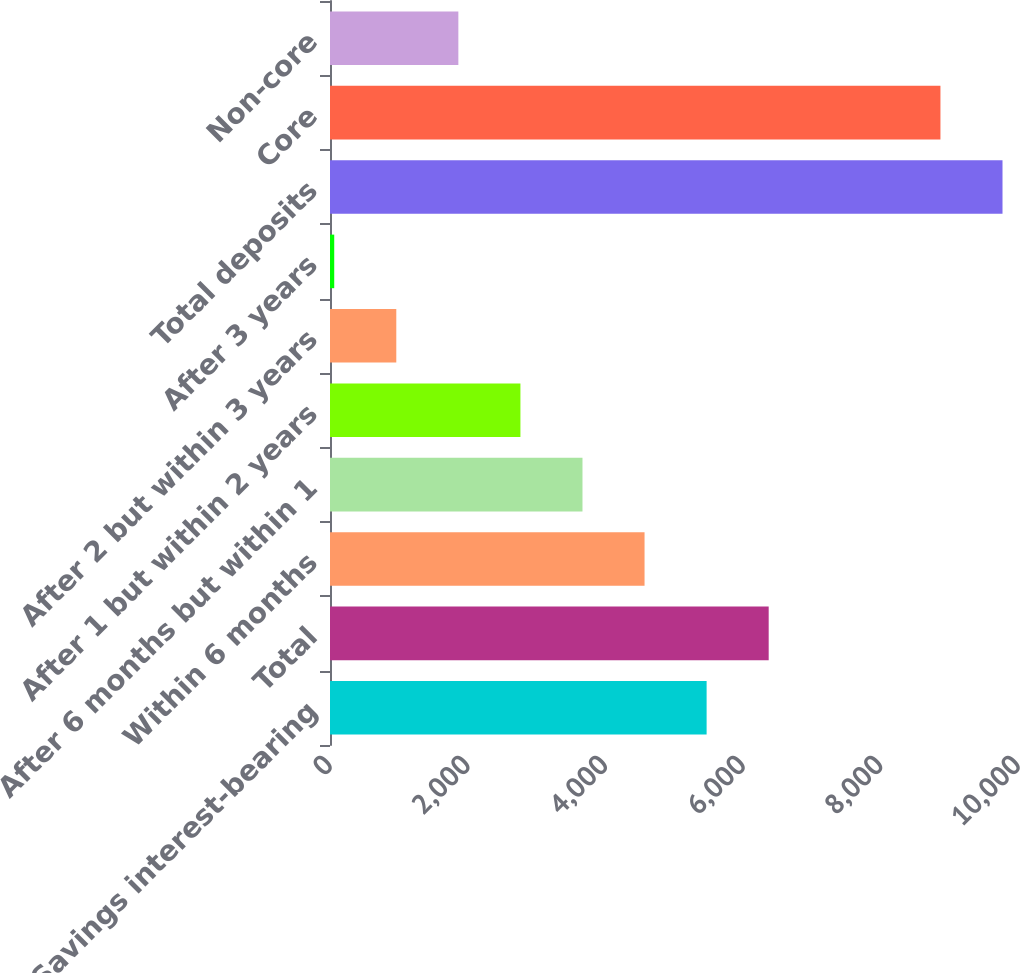Convert chart. <chart><loc_0><loc_0><loc_500><loc_500><bar_chart><fcel>Savings interest-bearing<fcel>Total<fcel>Within 6 months<fcel>After 6 months but within 1<fcel>After 1 but within 2 years<fcel>After 2 but within 3 years<fcel>After 3 years<fcel>Total deposits<fcel>Core<fcel>Non-core<nl><fcel>5474.12<fcel>6376.24<fcel>4572<fcel>3669.88<fcel>2767.76<fcel>963.52<fcel>61.4<fcel>9774.82<fcel>8872.7<fcel>1865.64<nl></chart> 